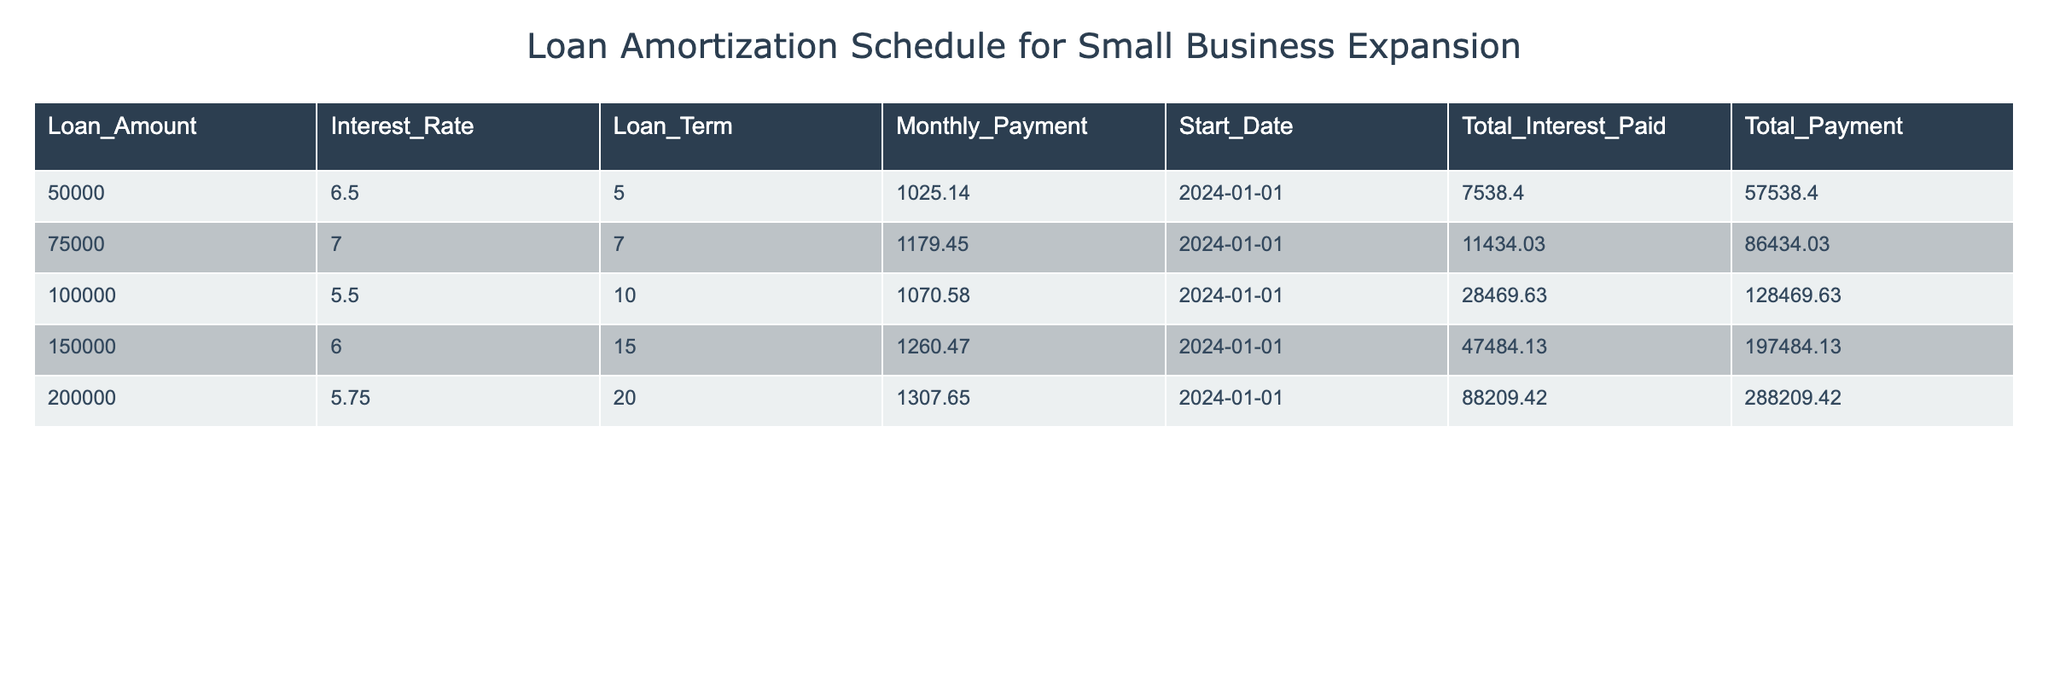What is the loan amount for the longest loan term listed? The longest loan term in the table is 20 years. Looking at the corresponding loan amounts, the loan amount for this term is 200000.
Answer: 200000 What is the total interest paid for the loan amount of 150000? In the table, the total interest paid for the loan amount of 150000 is listed as 47484.13.
Answer: 47484.13 Is the monthly payment for the loan amount of 75000 higher than that for the loan amount of 50000? The monthly payment for the loan amount of 75000 is 1179.45, while the monthly payment for the loan amount of 50000 is 1025.14. Since 1179.45 is greater than 1025.14, the answer is yes.
Answer: Yes What is the difference in total payments between the loan amount of 100000 and 150000? The total payment for the loan amount of 100000 is 128469.63, and for the loan amount of 150000, it is 197484.13. Calculating the difference: 197484.13 - 128469.63 = 69014.50.
Answer: 69014.50 What is the average total payment across all loan amounts presented? To find the average total payment, we sum the total payments: 57538.40 + 86434.03 + 128469.63 + 197484.13 + 288209.42 =  659135.61. There are 5 loan amounts, so the average total payment is 659135.61 / 5 = 131827.122.
Answer: 131827.12 